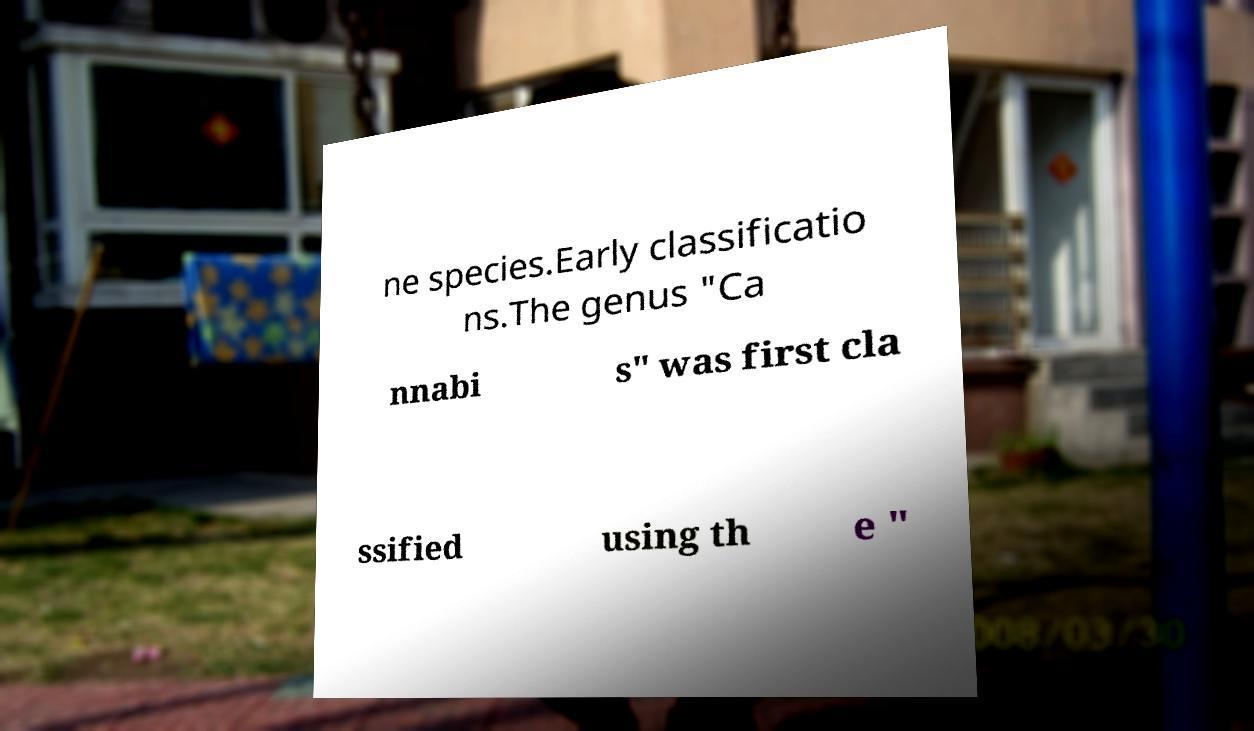Can you read and provide the text displayed in the image?This photo seems to have some interesting text. Can you extract and type it out for me? ne species.Early classificatio ns.The genus "Ca nnabi s" was first cla ssified using th e " 